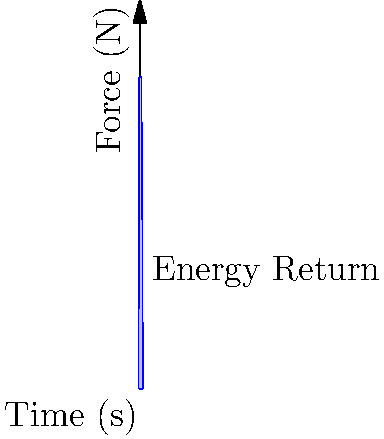Based on the force-time curve shown in the graph, which represents data from a force plate during product testing, how would you assess the energy return of the product? What key metric should be calculated, and how might this information be used to improve future product designs? To assess the energy return of the product using the force-time curve from force plate data, follow these steps:

1. Understand the graph: The blue curve represents the force applied over time during product testing, likely from a jumping or running activity.

2. Identify the key metric: The most important metric for energy return is the impulse, which is represented by the area under the force-time curve.

3. Calculate the impulse: Mathematically, impulse is given by the formula:

   $$ \text{Impulse} = \int_{t_1}^{t_2} F(t) dt $$

   Where $F(t)$ is the force as a function of time, and $t_1$ and $t_2$ are the start and end times of the impact.

4. Interpret the result: A larger impulse generally indicates greater energy return, as it represents more force applied over a longer duration.

5. Compare with motion capture data: Combine this information with motion capture data to calculate the efficiency of energy return:

   $$ \text{Efficiency} = \frac{\text{Energy Output}}{\text{Energy Input}} \times 100\% $$

6. Analyze for improvements: Look at the shape of the curve. A curve that rises quickly and maintains a high force for longer suggests better energy return.

7. Consider product modifications: Based on the analysis, suggest modifications such as:
   - Changes in material composition for better elasticity
   - Structural design alterations to optimize force distribution
   - Adjustments in product geometry to enhance energy storage and release

8. Iterative testing: Implement changes and retest, comparing new force-time curves with the original to quantify improvements.

By focusing on maximizing the area under the force-time curve (impulse) and improving the efficiency of energy return, you can guide product development towards designs with superior performance characteristics.
Answer: Calculate impulse (area under force-time curve) and efficiency; maximize for better energy return. 